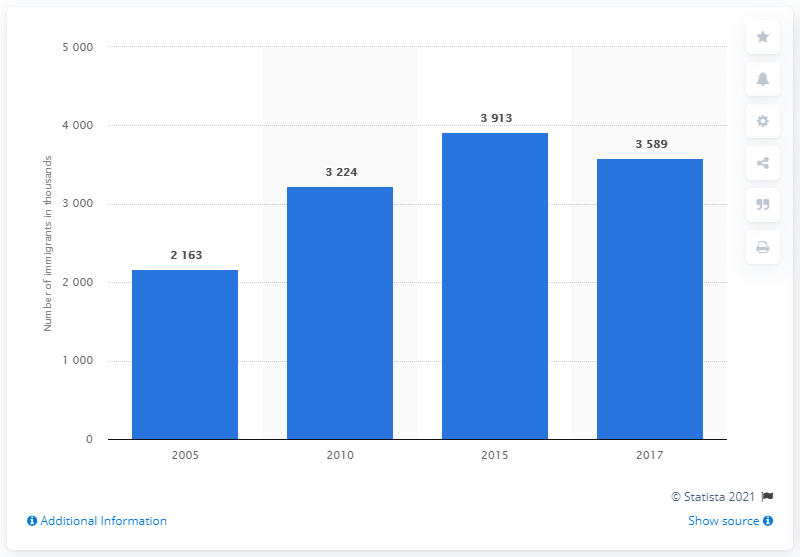Highlight a few significant elements in this photo. In 2010, approximately 3,224 immigrants lived in Thailand. 